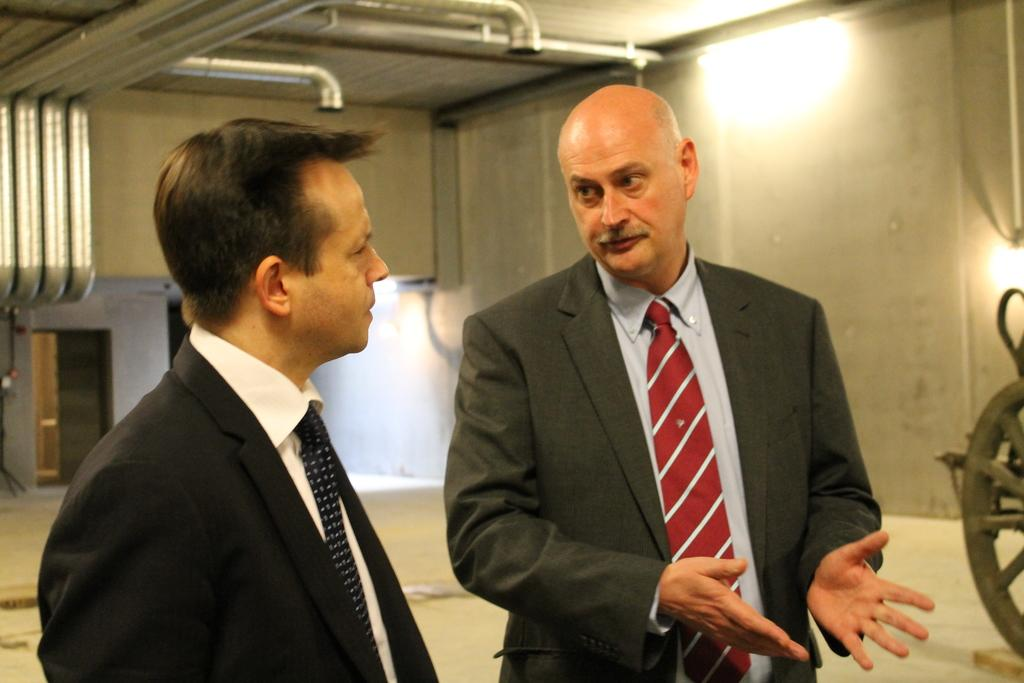How many people are present in the image? There are two people standing in the image. What can be seen in the background of the image? There is a wall and lights in the background of the image. What is visible at the top of the image? There are pipes visible at the top of the image. What type of prose is being recited by the people in the image? There is no indication in the image that the people are reciting any prose. 